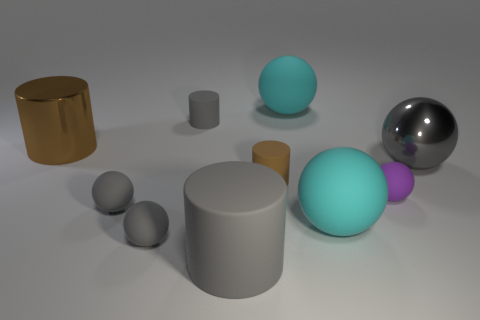What color is the large shiny ball?
Provide a short and direct response. Gray. There is a big cyan rubber object that is in front of the small gray cylinder; is its shape the same as the purple thing?
Offer a terse response. Yes. There is a large matte thing that is behind the big cyan rubber ball that is to the right of the large matte thing that is behind the large brown cylinder; what shape is it?
Your answer should be compact. Sphere. There is a brown cylinder that is in front of the large brown cylinder; what is it made of?
Ensure brevity in your answer.  Rubber. What is the color of the metal cylinder that is the same size as the gray shiny thing?
Your answer should be compact. Brown. What number of other things are there of the same shape as the small brown object?
Your response must be concise. 3. Do the gray metallic sphere and the brown rubber thing have the same size?
Offer a terse response. No. Is the number of cyan rubber things that are behind the large gray metallic thing greater than the number of gray shiny things left of the small gray cylinder?
Your answer should be very brief. Yes. What number of other things are the same size as the gray metallic sphere?
Provide a short and direct response. 4. There is a tiny sphere right of the big gray rubber object; is it the same color as the large matte cylinder?
Keep it short and to the point. No. 